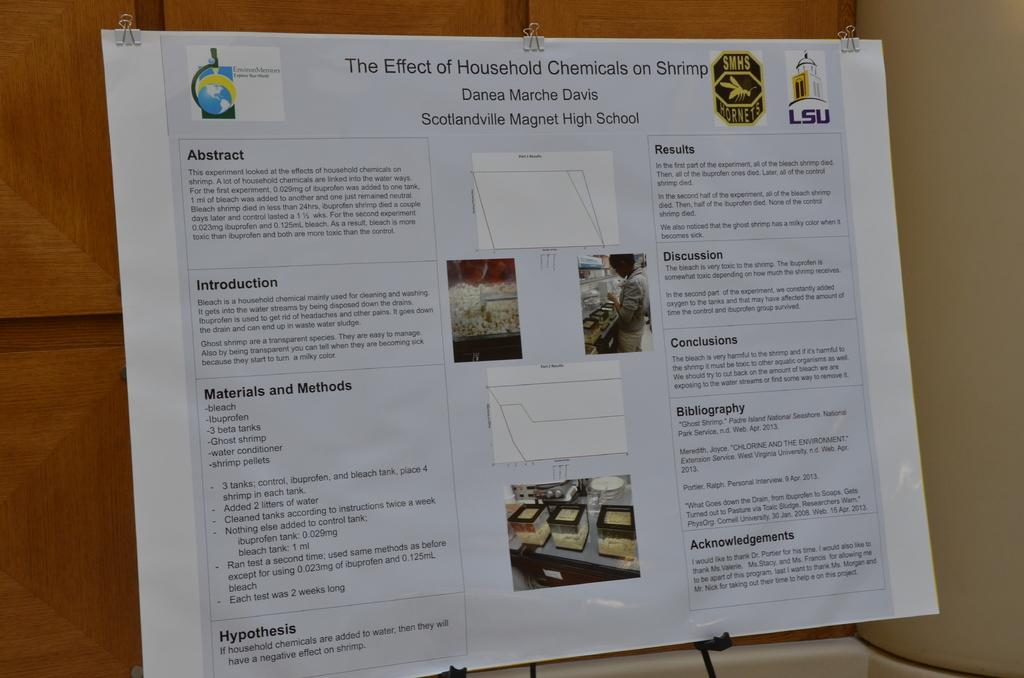<image>
Give a short and clear explanation of the subsequent image. The science project is about the effect of household chemicals on shrimp. 